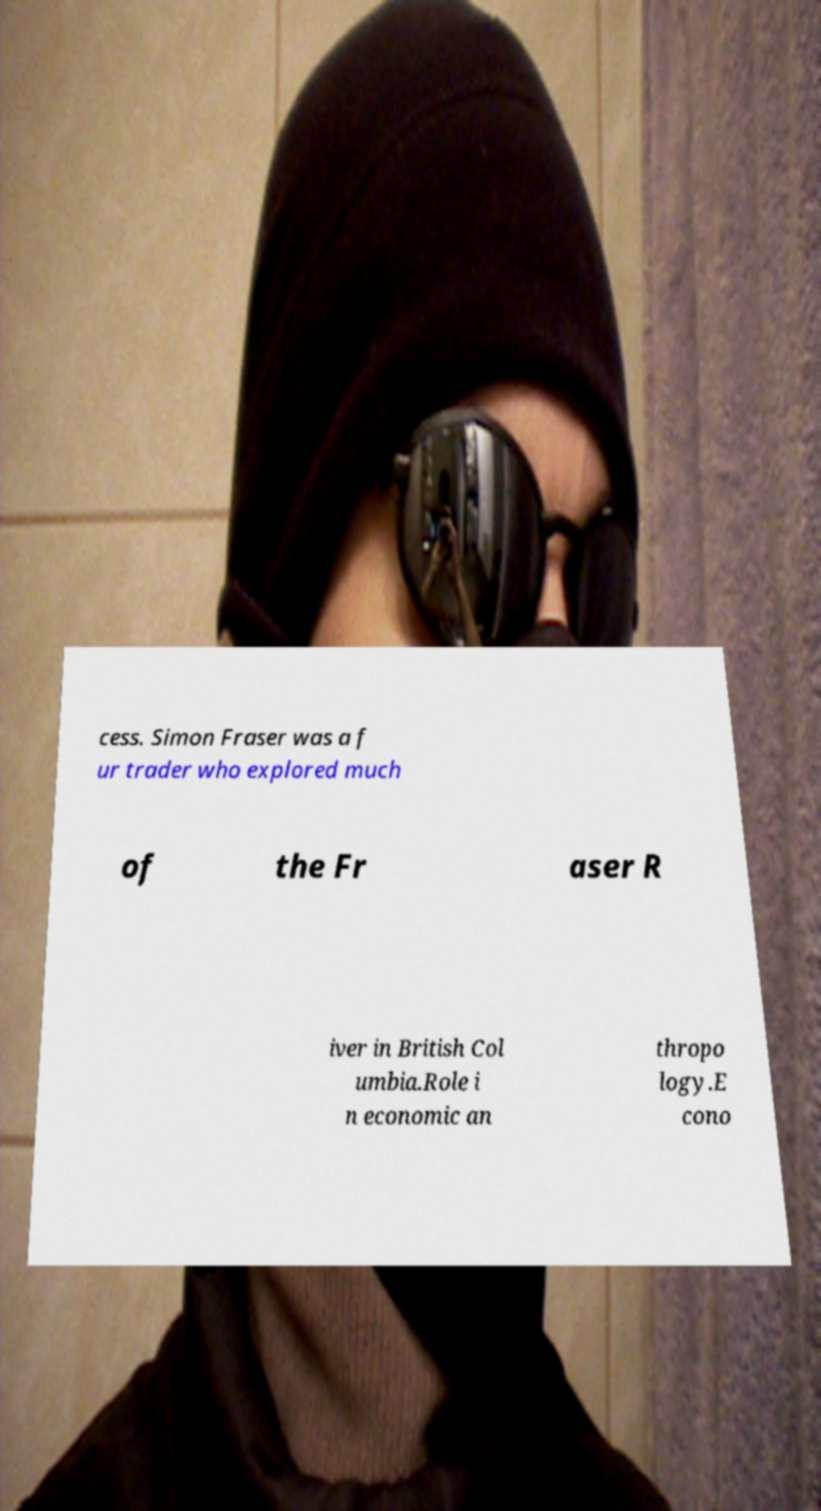Can you read and provide the text displayed in the image?This photo seems to have some interesting text. Can you extract and type it out for me? cess. Simon Fraser was a f ur trader who explored much of the Fr aser R iver in British Col umbia.Role i n economic an thropo logy.E cono 